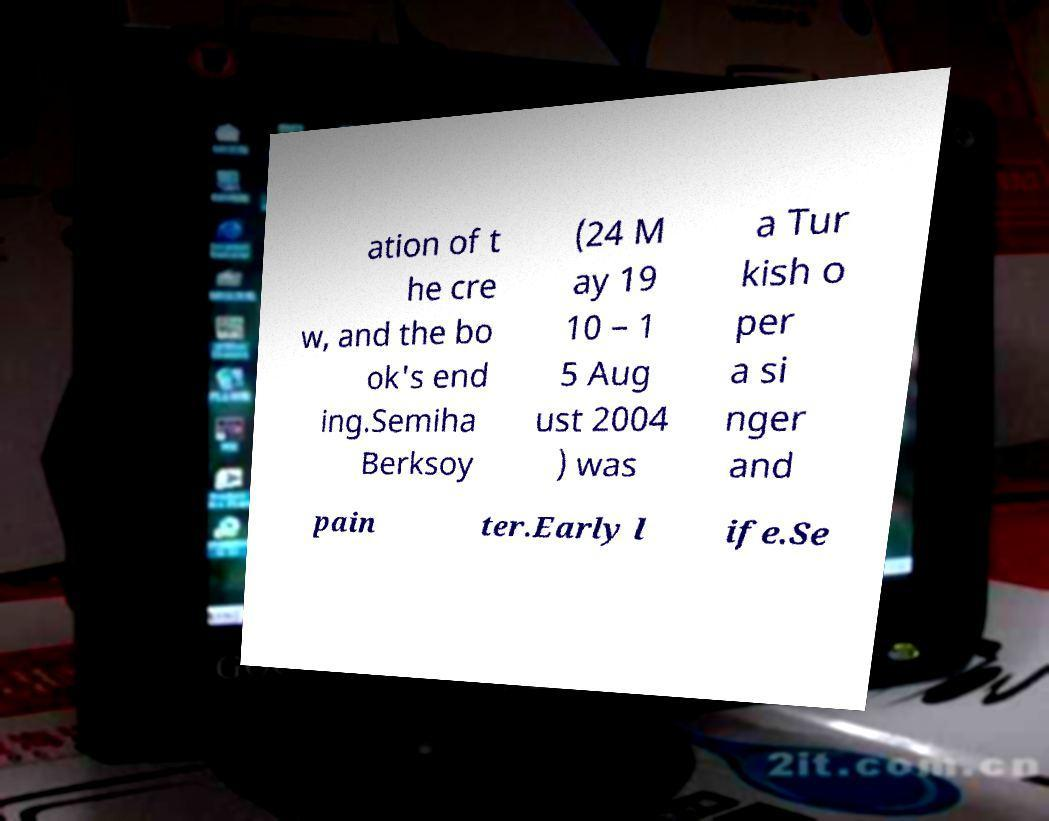I need the written content from this picture converted into text. Can you do that? ation of t he cre w, and the bo ok's end ing.Semiha Berksoy (24 M ay 19 10 – 1 5 Aug ust 2004 ) was a Tur kish o per a si nger and pain ter.Early l ife.Se 